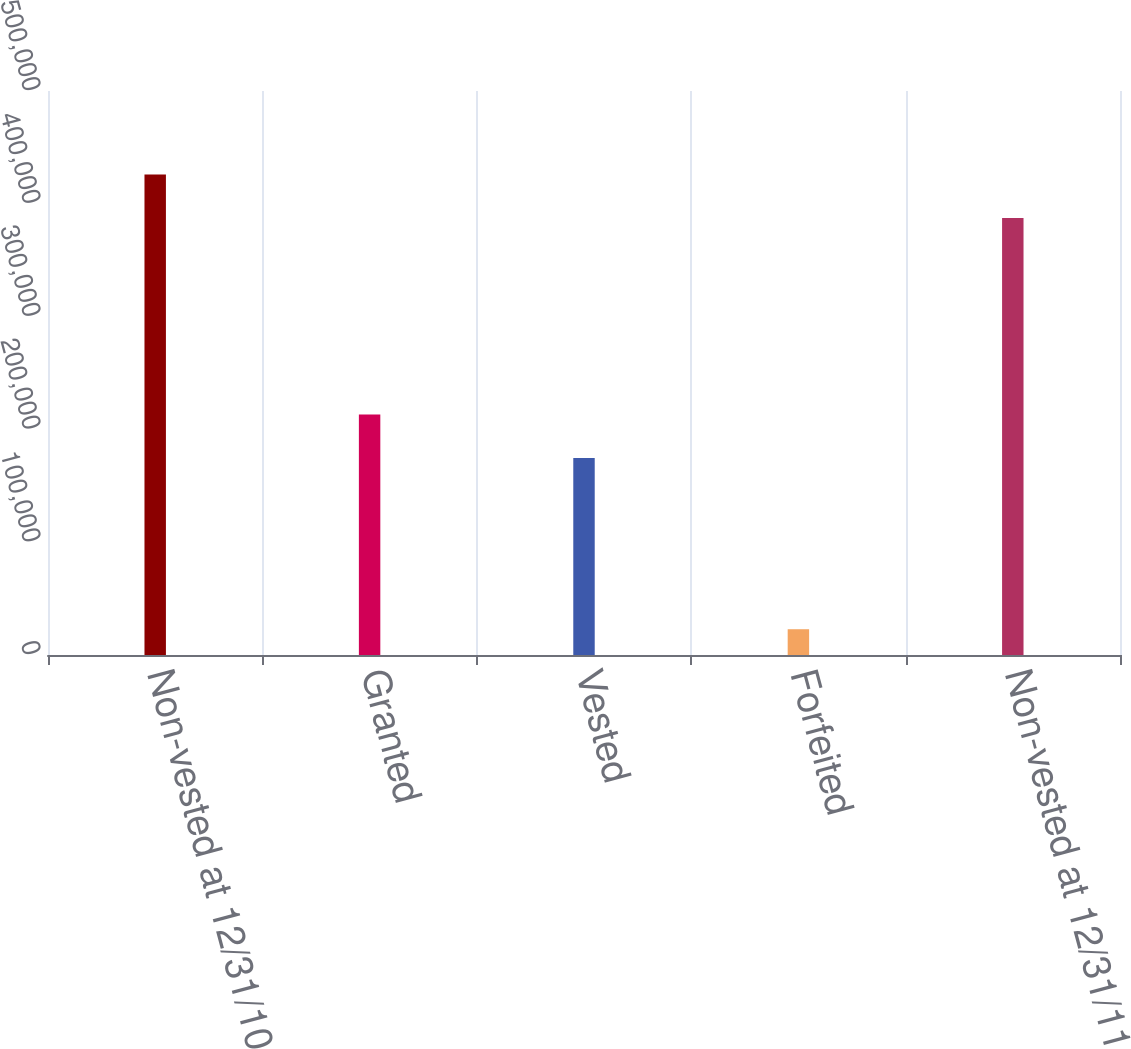<chart> <loc_0><loc_0><loc_500><loc_500><bar_chart><fcel>Non-vested at 12/31/10<fcel>Granted<fcel>Vested<fcel>Forfeited<fcel>Non-vested at 12/31/11<nl><fcel>425880<fcel>213213<fcel>174712<fcel>22847<fcel>387379<nl></chart> 